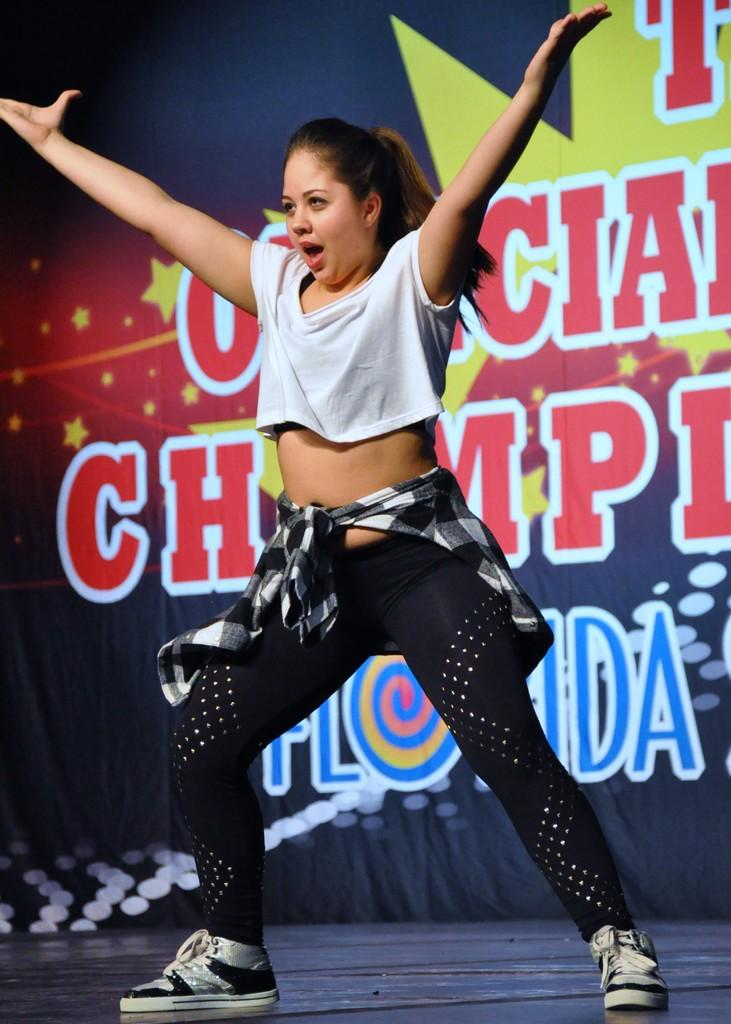What is the woman in the image doing? The woman is performing in the image. On what surface is the performance taking place? The performance is taking place on a surface. What can be seen in the background of the image? There is a banner in the background of the image. What information is present on the banner? The banner contains text and symbols. What type of powder is being used by the woman during her performance? There is no indication of any powder being used in the image; the woman is simply performing. How many arms does the woman have in the image? The woman has two arms, as is typical for humans. 